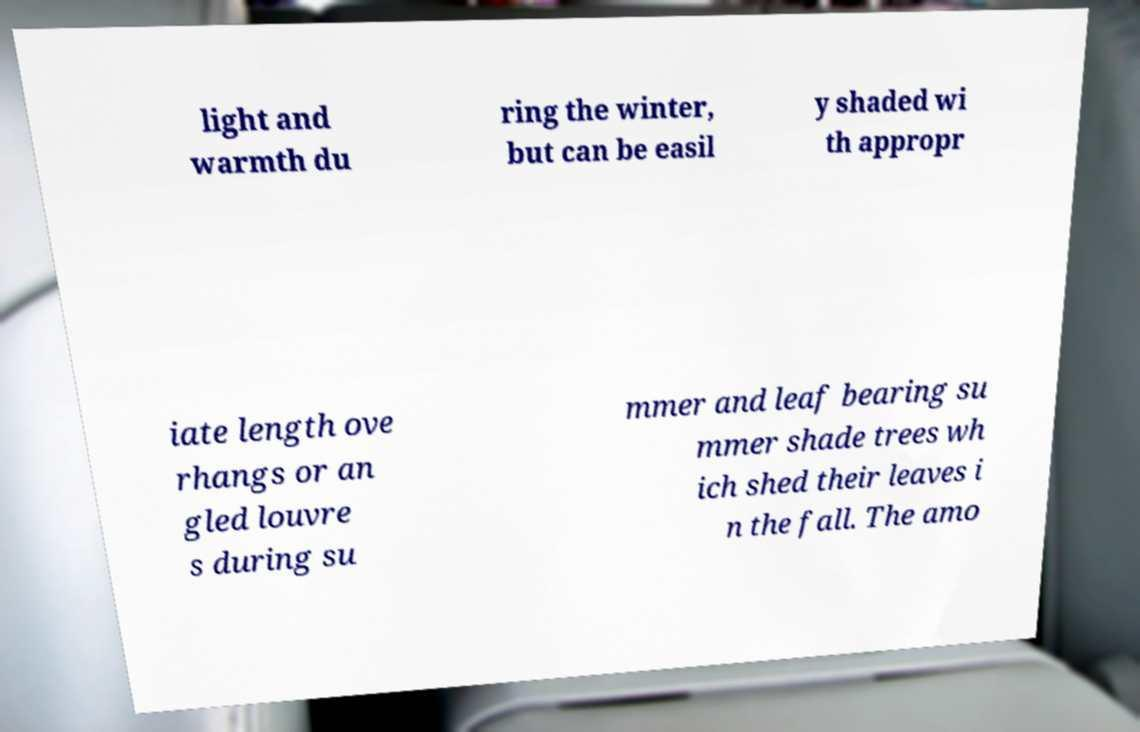Could you extract and type out the text from this image? light and warmth du ring the winter, but can be easil y shaded wi th appropr iate length ove rhangs or an gled louvre s during su mmer and leaf bearing su mmer shade trees wh ich shed their leaves i n the fall. The amo 